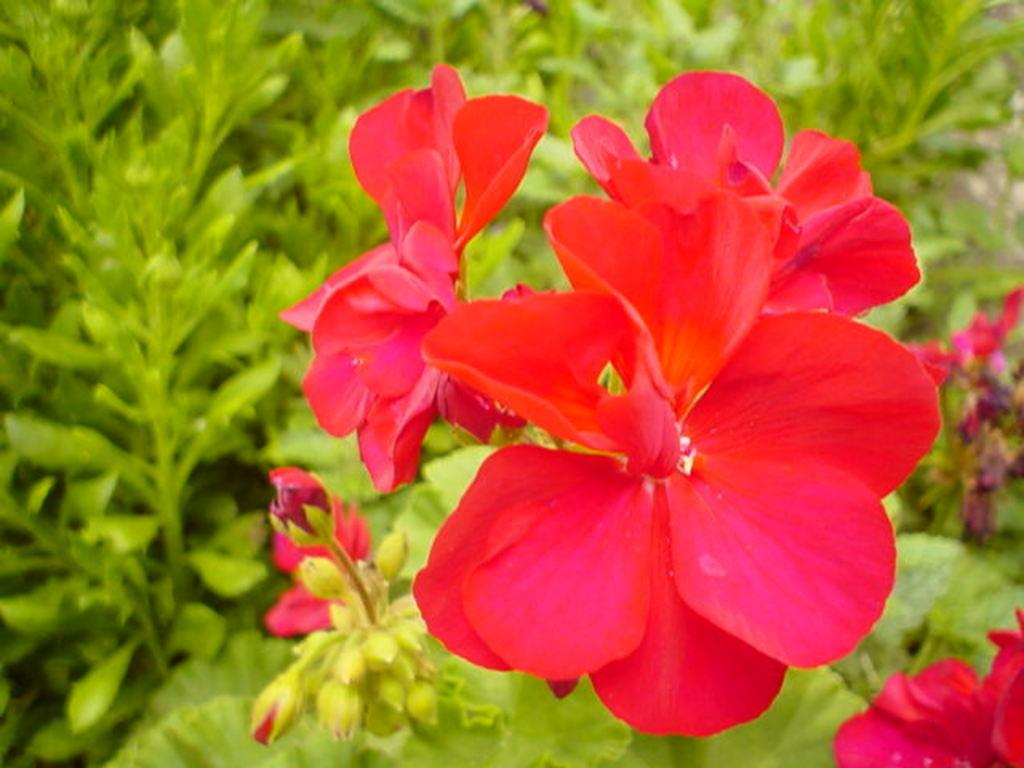What type of living organisms can be seen in the image? Plants can be seen in the image. What features can be observed on the plants? The plants have leaves, buds, and flowers. What color are the flowers on the plants? The flowers are red in color. How many pies are visible in the image? There are no pies present in the image. Can you describe the ear of the person in the image? There is no person present in the image, so it is not possible to describe their ear. 